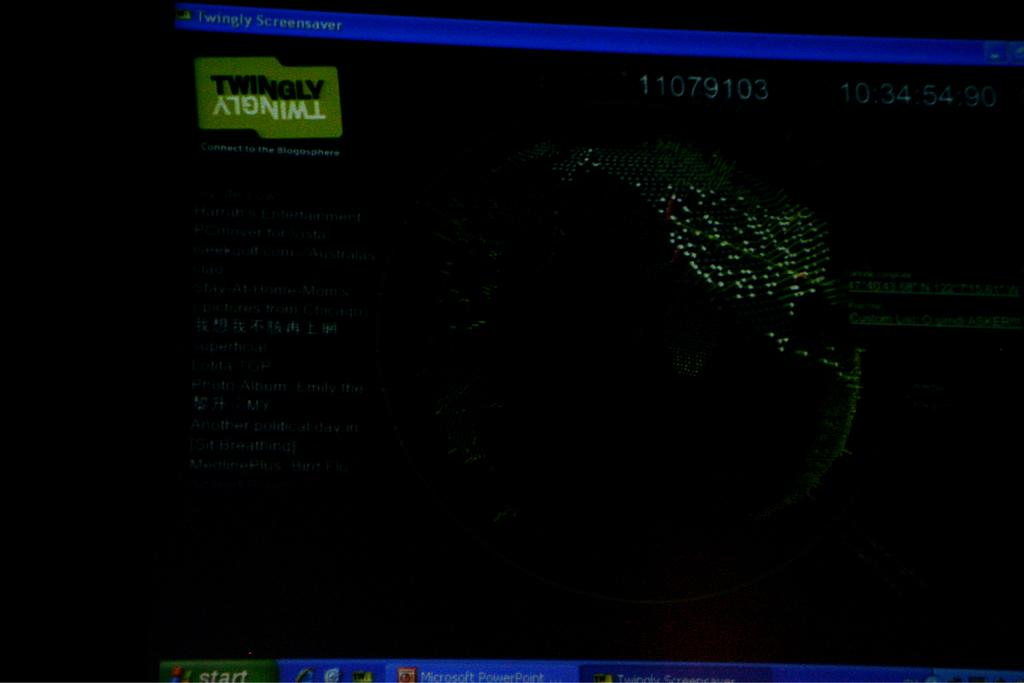<image>
Relay a brief, clear account of the picture shown. Very dim windows XP screen adjusting twingly screensaver. 